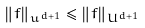Convert formula to latex. <formula><loc_0><loc_0><loc_500><loc_500>\| f \| _ { u ^ { d + 1 } } \leq \| f \| _ { U ^ { d + 1 } }</formula> 